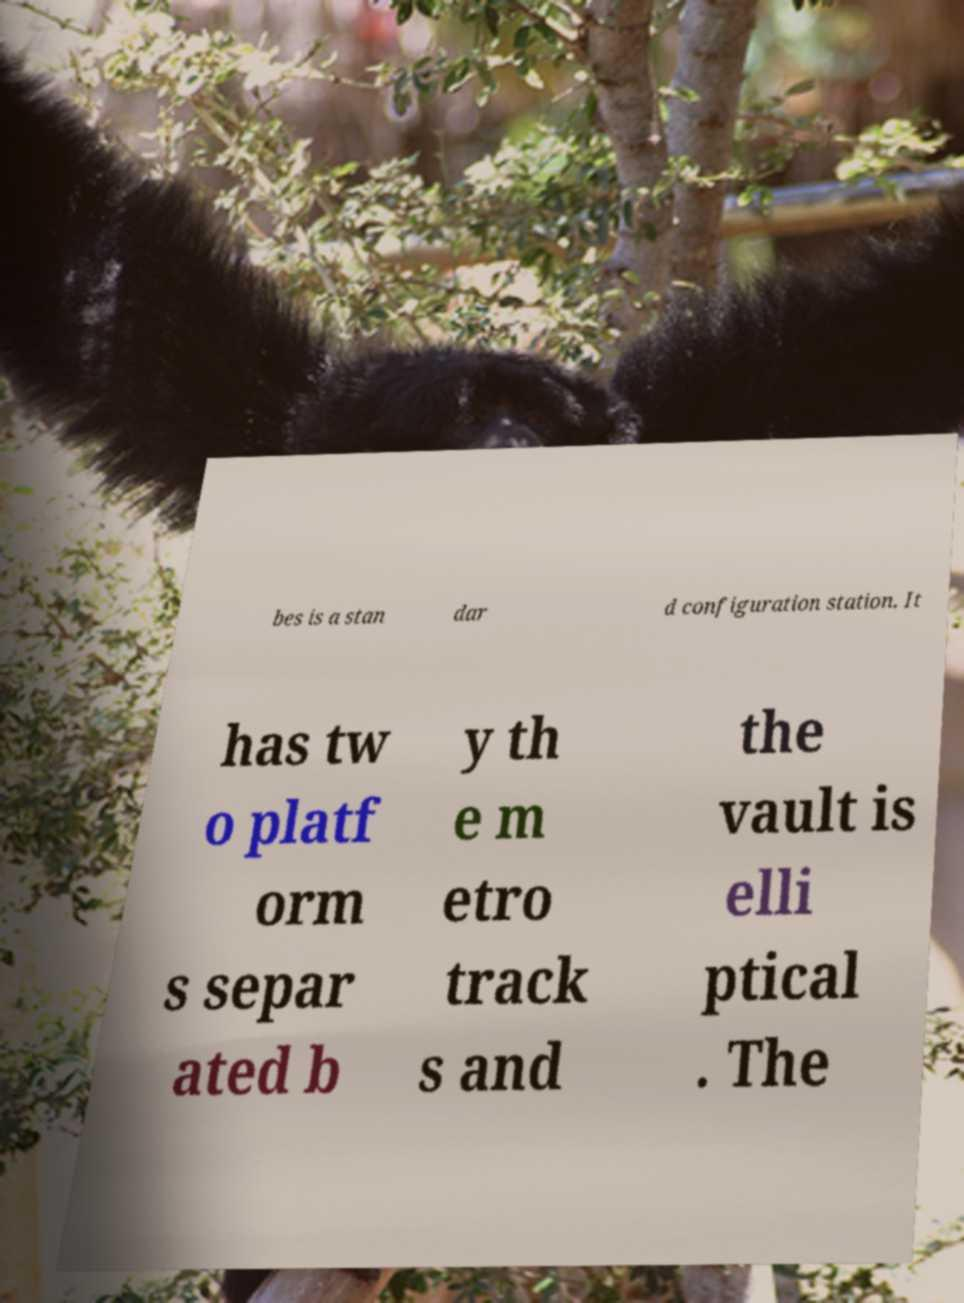I need the written content from this picture converted into text. Can you do that? bes is a stan dar d configuration station. It has tw o platf orm s separ ated b y th e m etro track s and the vault is elli ptical . The 